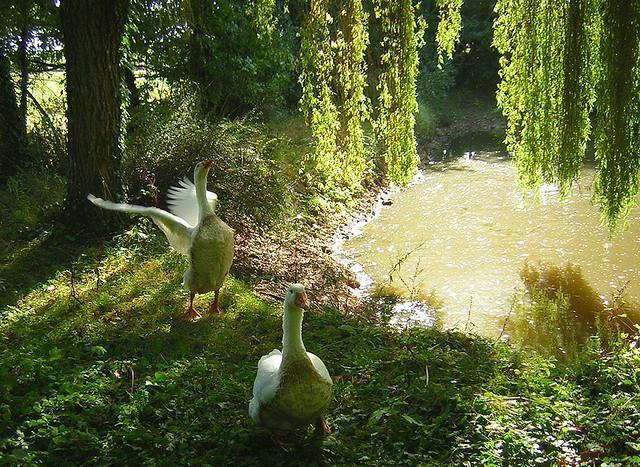How many geese are there?
Give a very brief answer. 2. How many birds are in the photo?
Give a very brief answer. 2. 